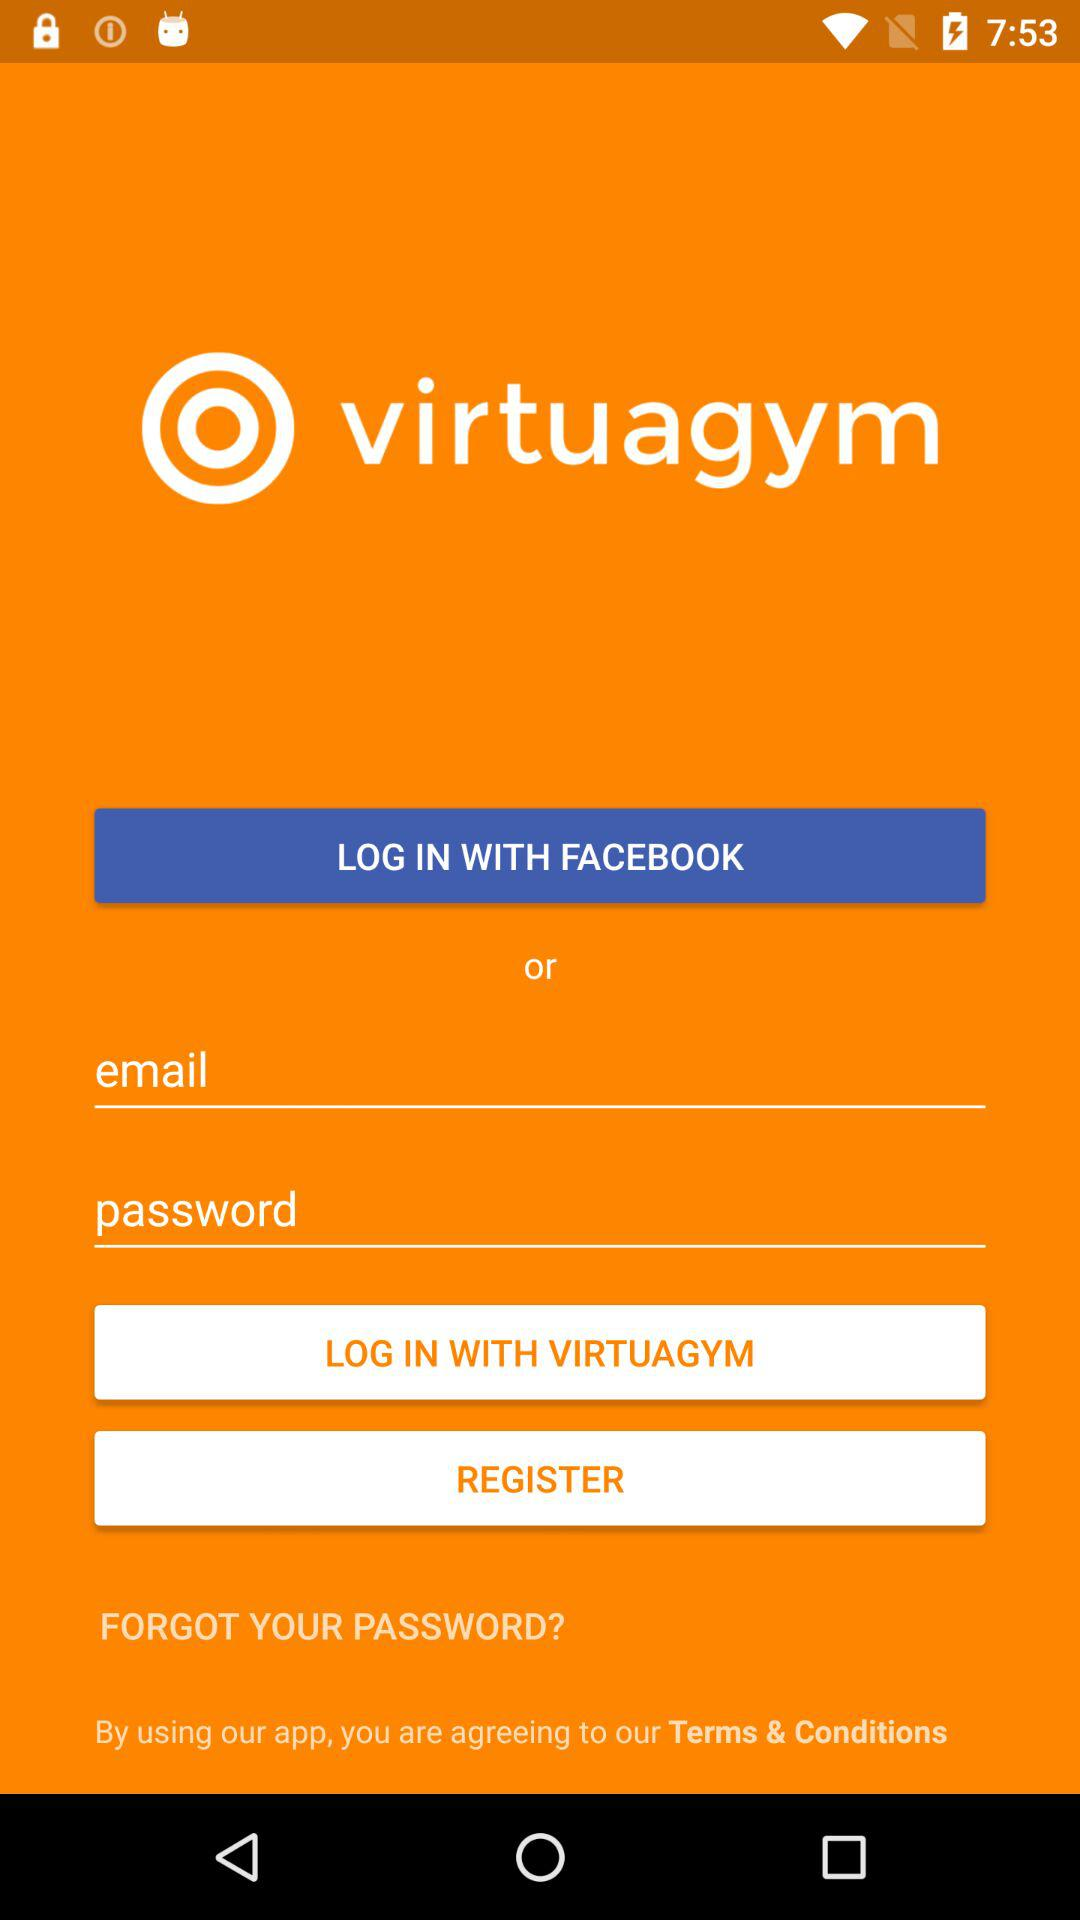What is the name of the application? The name of the application is "virtuagym". 